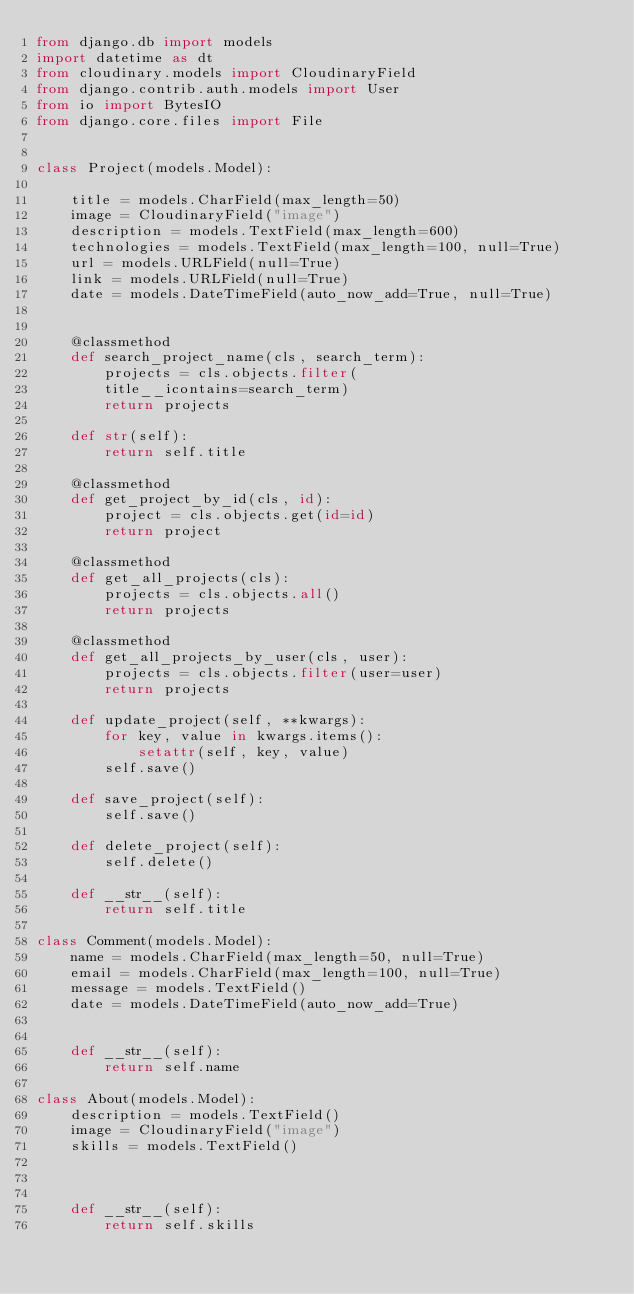Convert code to text. <code><loc_0><loc_0><loc_500><loc_500><_Python_>from django.db import models
import datetime as dt
from cloudinary.models import CloudinaryField
from django.contrib.auth.models import User
from io import BytesIO
from django.core.files import File


class Project(models.Model):
   
    title = models.CharField(max_length=50)
    image = CloudinaryField("image")
    description = models.TextField(max_length=600)
    technologies = models.TextField(max_length=100, null=True)
    url = models.URLField(null=True)
    link = models.URLField(null=True)
    date = models.DateTimeField(auto_now_add=True, null=True)

    
    @classmethod
    def search_project_name(cls, search_term):
        projects = cls.objects.filter(
        title__icontains=search_term)
        return projects    

    def str(self):
        return self.title

    @classmethod
    def get_project_by_id(cls, id):
        project = cls.objects.get(id=id)
        return project

    @classmethod
    def get_all_projects(cls):
        projects = cls.objects.all()
        return projects

    @classmethod
    def get_all_projects_by_user(cls, user):
        projects = cls.objects.filter(user=user)
        return projects

    def update_project(self, **kwargs):
        for key, value in kwargs.items():
            setattr(self, key, value)
        self.save()

    def save_project(self):
        self.save()

    def delete_project(self):
        self.delete()

    def __str__(self):
        return self.title

class Comment(models.Model):
    name = models.CharField(max_length=50, null=True)
    email = models.CharField(max_length=100, null=True)
    message = models.TextField()
    date = models.DateTimeField(auto_now_add=True)
    
    
    def __str__(self):
        return self.name

class About(models.Model):
    description = models.TextField()
    image = CloudinaryField("image")
    skills = models.TextField()
    
    
    
    def __str__(self):
        return self.skills</code> 